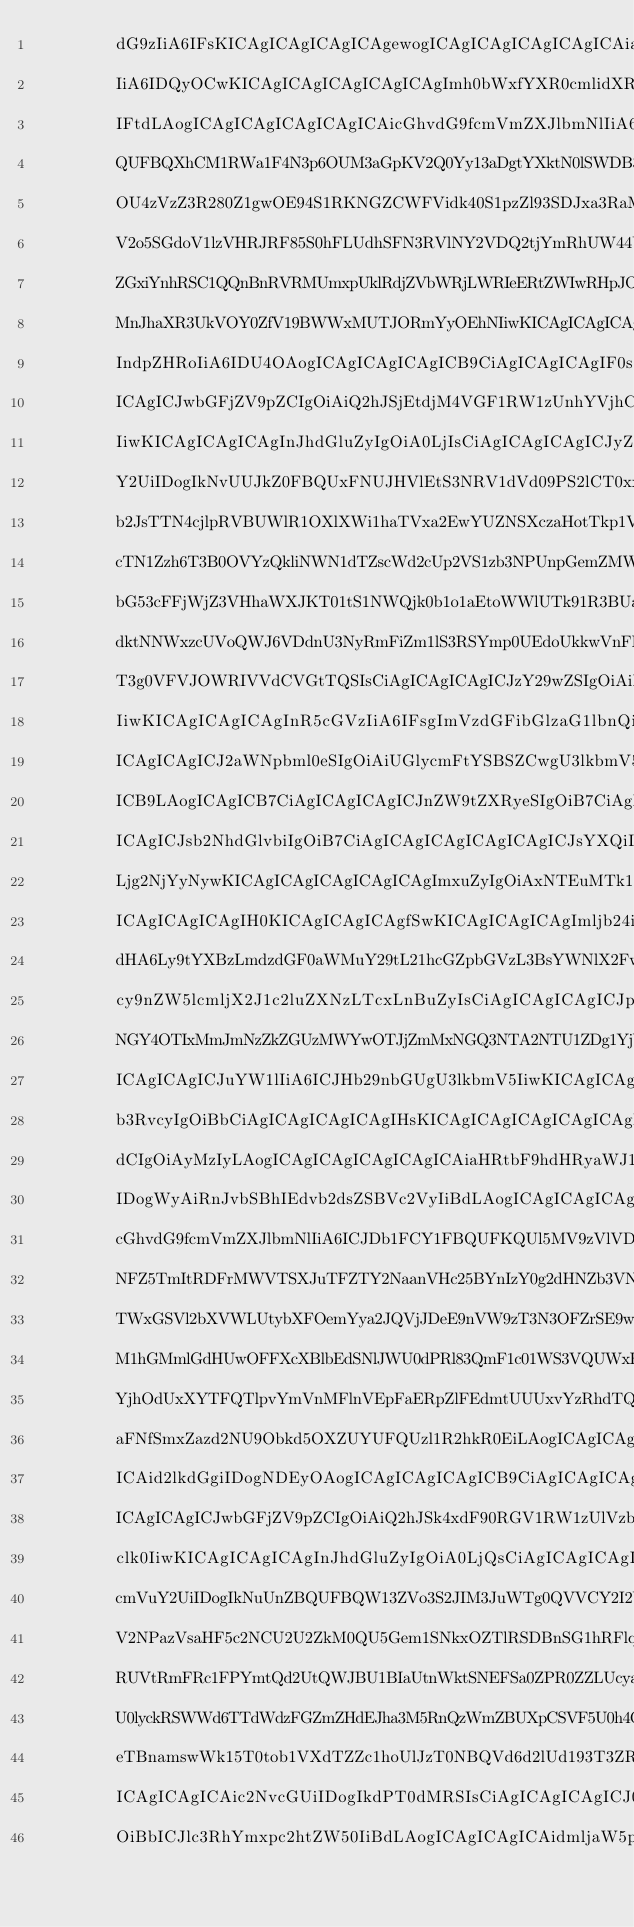Convert code to text. <code><loc_0><loc_0><loc_500><loc_500><_YAML_>        dG9zIiA6IFsKICAgICAgICAgICAgewogICAgICAgICAgICAgICAiaGVpZ2h0
        IiA6IDQyOCwKICAgICAgICAgICAgICAgImh0bWxfYXR0cmlidXRpb25zIiA6
        IFtdLAogICAgICAgICAgICAgICAicGhvdG9fcmVmZXJlbmNlIiA6ICJDblJu
        QUFBQXhCM1RWa1F4N3p6OUM3aGpKV2Q0Yy13aDgtYXktN0lSWDB3T3lVN29E
        OU4zVzZ3R280Z1gwOE94S1RKNGZCWFVidk40S1pzZl93SDJxa3RaM1hweVRo
        V2o5SGdoV1lzVHRJRF85S0hFLUdhSFN3RVlNY2VDQ2tjYmRhUW44UFFRS0dZ
        ZGxiYnhRSC1QQnBnRVRMUmxpUklRdjZVbWRjLWRIeERtZWIwRHpJOWM2eG9V
        MnJhaXR3UkVOY0ZfV19BWWxMUTJORmYyOEhNIiwKICAgICAgICAgICAgICAg
        IndpZHRoIiA6IDU4OAogICAgICAgICAgICB9CiAgICAgICAgIF0sCiAgICAg
        ICAgICJwbGFjZV9pZCIgOiAiQ2hJSjEtdjM4VGF1RW1zUnhYVjhCSjUzRnE0
        IiwKICAgICAgICAgInJhdGluZyIgOiA0LjIsCiAgICAgICAgICJyZWZlcmVu
        Y2UiIDogIkNvUUJkZ0FBQUxFNUJHVlEtS3NRV1dVd09PS2lCT0xxT1JydlRs
        b2JsTTN4cjlpRVBUWlR1OXlXWi1haTVxa2EwYUZNSXczaHotTkp1V1dZZWJT
        cTN1Zzh6T3B0OVYzQkliNWN1dTZscWd2cUp2VS1zb3NPUnpGemZMWmtaM1NN
        bG53cFFjWjZ3VHhaWXJKT01tS1NWQjk0b1o1aEtoWWlUTk91R3BUaVgwTTRt
        dktNNWxzcUVoQWJ6VDdnU3NyRmFiZm1lS3RSYmp0UEdoUkkwVnFPR05qS1pu
        T3g0VFVJOWRIVVdCVGtTQSIsCiAgICAgICAgICJzY29wZSIgOiAiR09PR0xF
        IiwKICAgICAgICAgInR5cGVzIiA6IFsgImVzdGFibGlzaG1lbnQiIF0sCiAg
        ICAgICAgICJ2aWNpbml0eSIgOiAiUGlycmFtYSBSZCwgU3lkbmV5IgogICAg
        ICB9LAogICAgICB7CiAgICAgICAgICJnZW9tZXRyeSIgOiB7CiAgICAgICAg
        ICAgICJsb2NhdGlvbiIgOiB7CiAgICAgICAgICAgICAgICJsYXQiIDogLTMz
        Ljg2NjYyNywKICAgICAgICAgICAgICAgImxuZyIgOiAxNTEuMTk1ODc2CiAg
        ICAgICAgICAgIH0KICAgICAgICAgfSwKICAgICAgICAgImljb24iIDogImh0
        dHA6Ly9tYXBzLmdzdGF0aWMuY29tL21hcGZpbGVzL3BsYWNlX2FwaS9pY29u
        cy9nZW5lcmljX2J1c2luZXNzLTcxLnBuZyIsCiAgICAgICAgICJpZCIgOiAi
        NGY4OTIxMmJmNzZkZGUzMWYwOTJjZmMxNGQ3NTA2NTU1ZDg1YjVjNyIsCiAg
        ICAgICAgICJuYW1lIiA6ICJHb29nbGUgU3lkbmV5IiwKICAgICAgICAgInBo
        b3RvcyIgOiBbCiAgICAgICAgICAgIHsKICAgICAgICAgICAgICAgImhlaWdo
        dCIgOiAyMzIyLAogICAgICAgICAgICAgICAiaHRtbF9hdHRyaWJ1dGlvbnMi
        IDogWyAiRnJvbSBhIEdvb2dsZSBVc2VyIiBdLAogICAgICAgICAgICAgICAi
        cGhvdG9fcmVmZXJlbmNlIiA6ICJDb1FCY1FBQUFKQUl5MV9zVlVDek0wdHdE
        NFZ5TmItRDFrMWVTSXJuTFZTY2NaanVHc25BYnIzY0g2dHNZb3VNbFNGU2ts
        TWxGSVl2bXVWLUtybXFOemYya2JQVjJDeE9nVW9zT3N3OFZrSE9wRS03M1JD
        M1hGMmlGdHUwOFFXcXBlbEdSNlJWU0dPRl83QmF1c01WS3VQUWxHNjBjTGdo
        YjhOdUxXYTFQTlpvYmVnMFlnVEpFaERpZlFEdmtUUUxvYzRhdTQ1SklOc09H
        aFNfSmxZazd2NU9Obkd5OXZUYUFQUzl1R2hkR0EiLAogICAgICAgICAgICAg
        ICAid2lkdGgiIDogNDEyOAogICAgICAgICAgICB9CiAgICAgICAgIF0sCiAg
        ICAgICAgICJwbGFjZV9pZCIgOiAiQ2hJSk4xdF90RGV1RW1zUlVzb3lHODNm
        clk0IiwKICAgICAgICAgInJhdGluZyIgOiA0LjQsCiAgICAgICAgICJyZWZl
        cmVuY2UiIDogIkNuUnZBQUFBQW13ZVo3S2JIM3JuWTg0QVVCY2I2YUU0c3pK
        V2NPazVsaHF5c2NCU2U2ZkM0QU5Gem1SNkxOZTlRSDBnSG1hRFlqSjdaN21W
        RUVtRmFRc1FPYmtQd2UtQWJBU1BIaUtnWktSNEFSa0ZPR0ZZLUcyakFVVG5O
        U0lyckRSWWd6TTdWdzFGZmZHdEJha3M5RnQzWmZBUXpCSVF5U0h4QWRjNm51
        eTBnamswWk15T0tob1VXdTZZc1hoUlJzT0NBQVd6d2lUd193T3ZRNkkiLAog
        ICAgICAgICAic2NvcGUiIDogIkdPT0dMRSIsCiAgICAgICAgICJ0eXBlcyIg
        OiBbICJlc3RhYmxpc2htZW50IiBdLAogICAgICAgICAidmljaW5pdHkiIDog</code> 